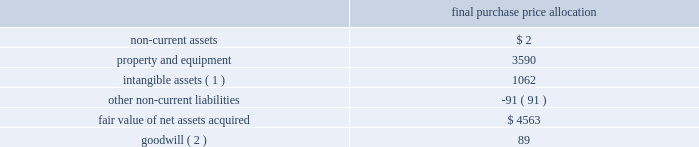American tower corporation and subsidiaries notes to consolidated financial statements the allocation of the purchase price was finalized during the year ended december 31 , 2012 .
The table summarizes the allocation of the aggregate purchase consideration paid and the amounts of assets acquired and liabilities assumed based upon their estimated fair value at the date of acquisition ( in thousands ) : purchase price allocation .
( 1 ) consists of customer-related intangibles of approximately $ 0.4 million and network location intangibles of approximately $ 0.7 million .
The customer-related intangibles and network location intangibles are being amortized on a straight-line basis over periods of up to 20 years .
( 2 ) the company expects that the goodwill recorded will be deductible for tax purposes .
The goodwill was allocated to the company 2019s international rental and management segment .
Colombia 2014colombia movil acquisition 2014on july 17 , 2011 , the company entered into a definitive agreement with colombia movil s.a .
E.s.p .
( 201ccolombia movil 201d ) , whereby atc sitios infraco , s.a.s. , a colombian subsidiary of the company ( 201catc infraco 201d ) , would purchase up to 2126 communications sites from colombia movil for an aggregate purchase price of approximately $ 182.0 million .
From december 21 , 2011 through the year ended december 31 , 2012 , atc infraco completed the purchase of 1526 communications sites for an aggregate purchase price of $ 136.2 million ( including contingent consideration of $ 17.3 million ) , subject to post-closing adjustments .
Through a subsidiary , millicom international cellular s.a .
( 201cmillicom 201d ) exercised its option to acquire an indirect , substantial non-controlling interest in atc infraco .
Under the terms of the agreement , the company is required to make additional payments upon the conversion of certain barter agreements with other wireless carriers to cash paying lease agreements .
Based on the company 2019s current estimates , the value of potential contingent consideration payments required to be made under the amended agreement is expected to be between zero and $ 32.8 million and is estimated to be $ 17.3 million using a probability weighted average of the expected outcomes at december 31 , 2012 .
During the year ended december 31 , 2012 , the company recorded a reduction in fair value of $ 1.2 million , which is included in other operating expenses in the consolidated statements of operations. .
For the 2012 acquisition , hard assets were what percent of the total fair value of net assets acquired? 
Rationale: ppe - hard assets
Computations: (3590 / 4563)
Answer: 0.78676. 